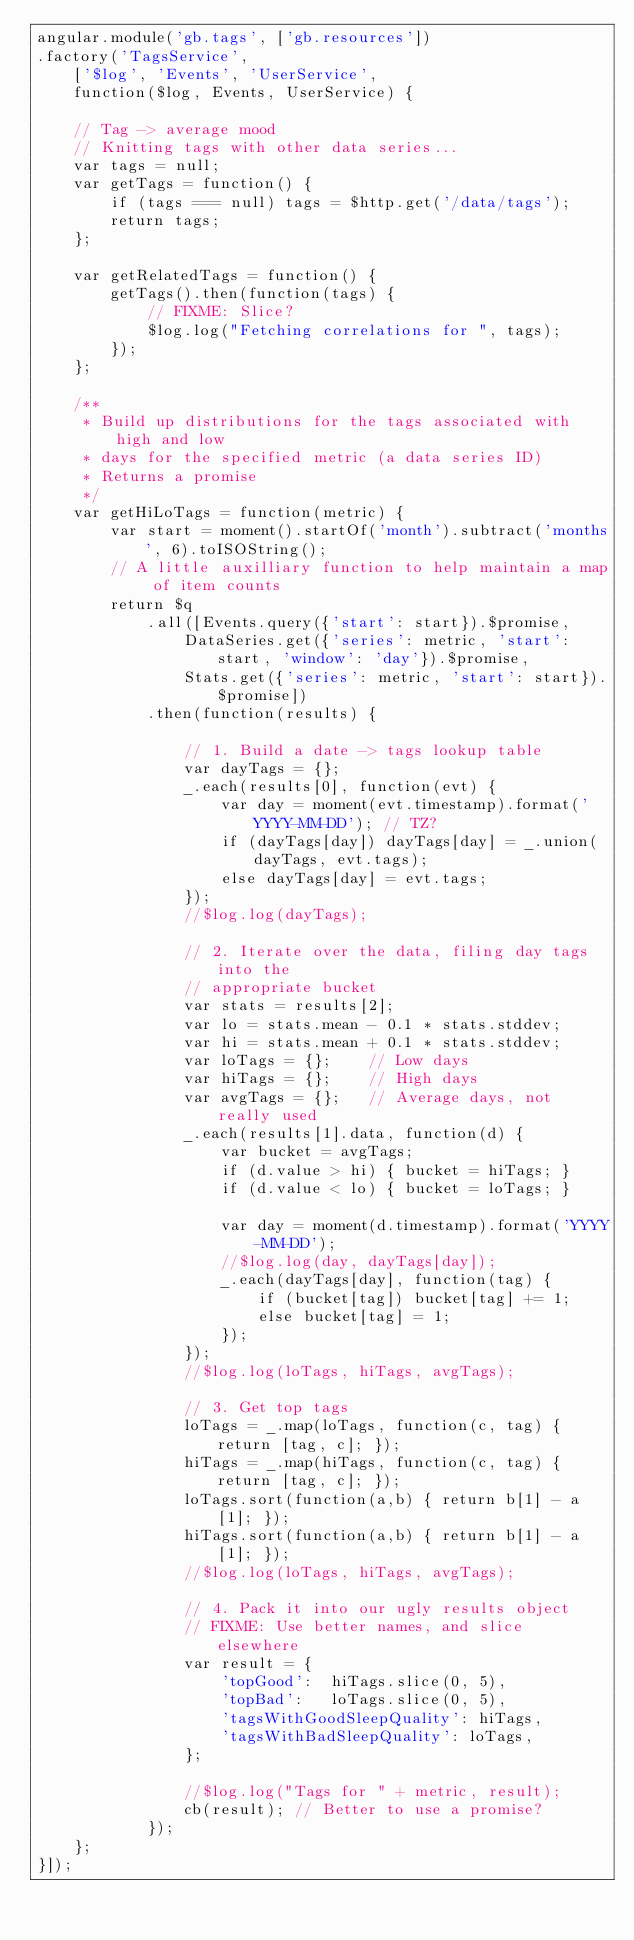Convert code to text. <code><loc_0><loc_0><loc_500><loc_500><_JavaScript_>angular.module('gb.tags', ['gb.resources'])
.factory('TagsService',
	['$log', 'Events', 'UserService',
	function($log, Events, UserService) {

	// Tag -> average mood
	// Knitting tags with other data series...
	var tags = null;
	var getTags = function() {
		if (tags === null) tags = $http.get('/data/tags');
		return tags;
	};

	var getRelatedTags = function() {
		getTags().then(function(tags) {
			// FIXME: Slice?
			$log.log("Fetching correlations for ", tags);
		});
	};

	/**
	 * Build up distributions for the tags associated with high and low
	 * days for the specified metric (a data series ID)
	 * Returns a promise
	 */
	var getHiLoTags = function(metric) {
		var start = moment().startOf('month').subtract('months', 6).toISOString();
		// A little auxilliary function to help maintain a map of item counts
		return $q
			.all([Events.query({'start': start}).$promise,
				DataSeries.get({'series': metric, 'start': start, 'window': 'day'}).$promise,
				Stats.get({'series': metric, 'start': start}).$promise])
			.then(function(results) {

				// 1. Build a date -> tags lookup table
				var dayTags = {};
				_.each(results[0], function(evt) {
					var day = moment(evt.timestamp).format('YYYY-MM-DD'); // TZ?
					if (dayTags[day]) dayTags[day] = _.union(dayTags, evt.tags);
					else dayTags[day] = evt.tags;
				});
				//$log.log(dayTags);

				// 2. Iterate over the data, filing day tags into the
				// appropriate bucket
				var stats = results[2];
				var lo = stats.mean - 0.1 * stats.stddev;
				var hi = stats.mean + 0.1 * stats.stddev;
				var loTags = {}; 	// Low days
				var hiTags = {}; 	// High days
				var avgTags = {}; 	// Average days, not really used
				_.each(results[1].data, function(d) {
					var bucket = avgTags;
					if (d.value > hi) { bucket = hiTags; }
					if (d.value < lo) { bucket = loTags; }

					var day = moment(d.timestamp).format('YYYY-MM-DD');
					//$log.log(day, dayTags[day]);
					_.each(dayTags[day], function(tag) {
						if (bucket[tag]) bucket[tag] += 1;
						else bucket[tag] = 1;
					});
				});
				//$log.log(loTags, hiTags, avgTags);

				// 3. Get top tags
				loTags = _.map(loTags, function(c, tag) { return [tag, c]; });
				hiTags = _.map(hiTags, function(c, tag) { return [tag, c]; });
				loTags.sort(function(a,b) { return b[1] - a[1]; });
				hiTags.sort(function(a,b) { return b[1] - a[1]; });
				//$log.log(loTags, hiTags, avgTags);

				// 4. Pack it into our ugly results object
				// FIXME: Use better names, and slice elsewhere
				var result = {
					'topGood': 	hiTags.slice(0, 5),
					'topBad': 	loTags.slice(0, 5),
					'tagsWithGoodSleepQuality': hiTags,
					'tagsWithBadSleepQuality': loTags,
				};

				//$log.log("Tags for " + metric, result);
				cb(result); // Better to use a promise?
			});
	};
}]);
</code> 